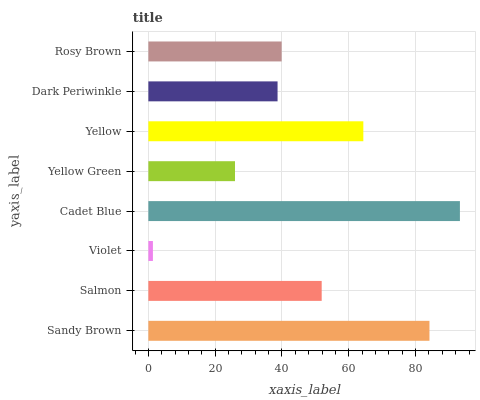Is Violet the minimum?
Answer yes or no. Yes. Is Cadet Blue the maximum?
Answer yes or no. Yes. Is Salmon the minimum?
Answer yes or no. No. Is Salmon the maximum?
Answer yes or no. No. Is Sandy Brown greater than Salmon?
Answer yes or no. Yes. Is Salmon less than Sandy Brown?
Answer yes or no. Yes. Is Salmon greater than Sandy Brown?
Answer yes or no. No. Is Sandy Brown less than Salmon?
Answer yes or no. No. Is Salmon the high median?
Answer yes or no. Yes. Is Rosy Brown the low median?
Answer yes or no. Yes. Is Yellow Green the high median?
Answer yes or no. No. Is Cadet Blue the low median?
Answer yes or no. No. 